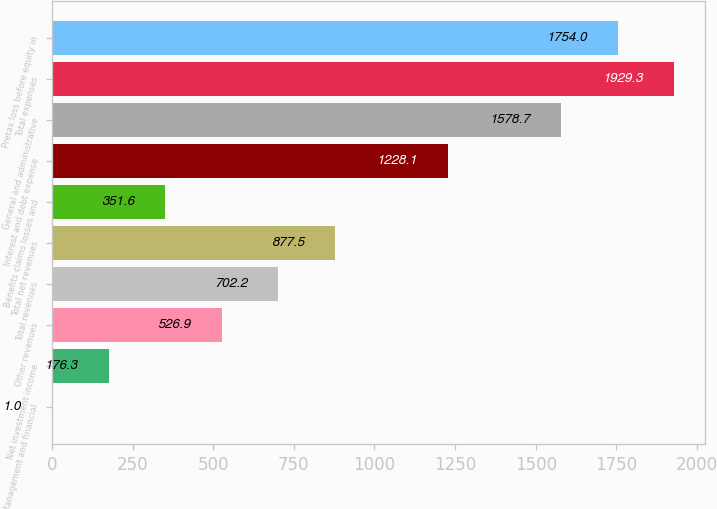Convert chart. <chart><loc_0><loc_0><loc_500><loc_500><bar_chart><fcel>Management and financial<fcel>Net investment income<fcel>Other revenues<fcel>Total revenues<fcel>Total net revenues<fcel>Benefits claims losses and<fcel>Interest and debt expense<fcel>General and administrative<fcel>Total expenses<fcel>Pretax loss before equity in<nl><fcel>1<fcel>176.3<fcel>526.9<fcel>702.2<fcel>877.5<fcel>351.6<fcel>1228.1<fcel>1578.7<fcel>1929.3<fcel>1754<nl></chart> 